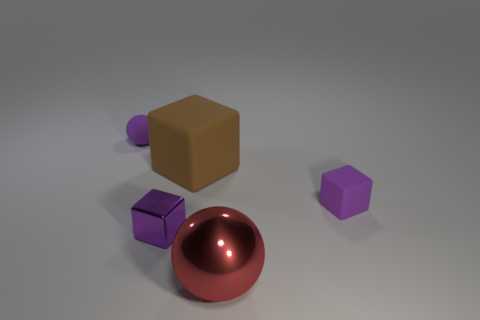There is a matte block that is the same size as the red shiny ball; what color is it?
Your response must be concise. Brown. Is there a small purple object?
Your answer should be very brief. Yes. What is the shape of the tiny purple rubber thing that is to the left of the big sphere?
Offer a very short reply. Sphere. How many things are both behind the small metal cube and right of the large block?
Your response must be concise. 1. Is there a small brown cube made of the same material as the tiny purple sphere?
Keep it short and to the point. No. The metal thing that is the same color as the small rubber ball is what size?
Your answer should be compact. Small. What number of cubes are either small gray shiny objects or big brown rubber objects?
Offer a terse response. 1. What is the size of the purple matte block?
Provide a short and direct response. Small. What number of blocks are left of the small purple metallic cube?
Offer a very short reply. 0. What is the size of the purple rubber thing to the right of the metal thing on the right side of the large rubber cube?
Offer a terse response. Small. 